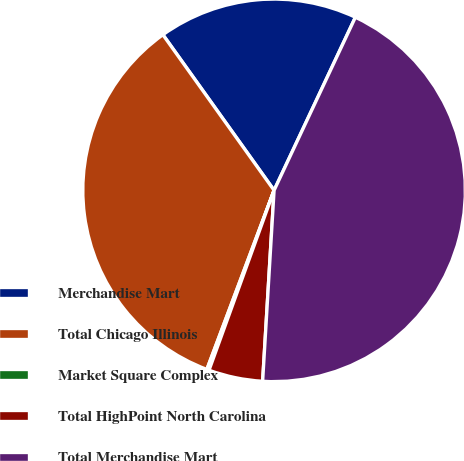<chart> <loc_0><loc_0><loc_500><loc_500><pie_chart><fcel>Merchandise Mart<fcel>Total Chicago Illinois<fcel>Market Square Complex<fcel>Total HighPoint North Carolina<fcel>Total Merchandise Mart<nl><fcel>16.86%<fcel>34.41%<fcel>0.19%<fcel>4.57%<fcel>43.96%<nl></chart> 